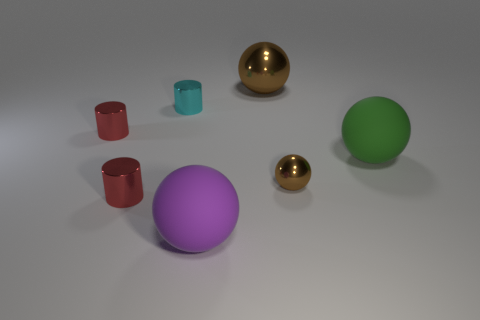The big sphere behind the sphere that is right of the tiny brown metal sphere in front of the large green object is what color?
Keep it short and to the point. Brown. There is a thing that is left of the big brown object and on the right side of the small cyan cylinder; how big is it?
Your answer should be very brief. Large. There is a brown metallic sphere that is behind the big green thing; are there any balls in front of it?
Your answer should be compact. Yes. What is the color of the other rubber object that is the same shape as the large purple object?
Offer a terse response. Green. Do the big thing behind the cyan cylinder and the big sphere that is in front of the large green thing have the same material?
Ensure brevity in your answer.  No. There is a tiny ball; is it the same color as the shiny ball that is behind the small brown thing?
Your answer should be very brief. Yes. What is the shape of the object that is both to the left of the big purple matte ball and in front of the tiny brown object?
Ensure brevity in your answer.  Cylinder. What number of tiny red things are there?
Provide a short and direct response. 2. There is a large object that is the same color as the small sphere; what shape is it?
Provide a succinct answer. Sphere. There is a green rubber object that is the same shape as the large brown metallic object; what size is it?
Provide a succinct answer. Large. 